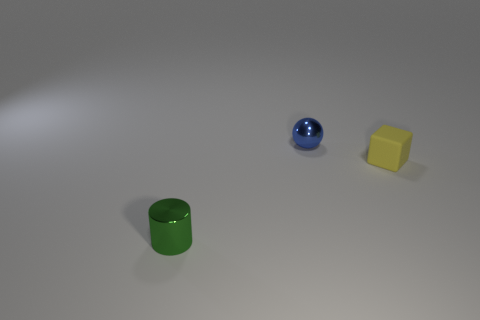Is there any other thing that is made of the same material as the cube?
Make the answer very short. No. There is a green object that is the same size as the ball; what is its material?
Keep it short and to the point. Metal. How many shiny objects are there?
Offer a very short reply. 2. What is the size of the shiny object behind the yellow rubber thing?
Provide a succinct answer. Small. Are there the same number of objects that are on the left side of the green shiny cylinder and brown matte cylinders?
Ensure brevity in your answer.  Yes. What is the shape of the thing that is both to the left of the small yellow matte thing and in front of the ball?
Offer a terse response. Cylinder. Are the sphere and the tiny object that is on the right side of the tiny sphere made of the same material?
Your answer should be very brief. No. Are there any green cylinders left of the yellow rubber thing?
Give a very brief answer. Yes. What number of objects are either big yellow matte cubes or objects in front of the blue metallic ball?
Ensure brevity in your answer.  2. There is a tiny metal object that is in front of the shiny thing behind the tiny yellow thing; what color is it?
Give a very brief answer. Green. 